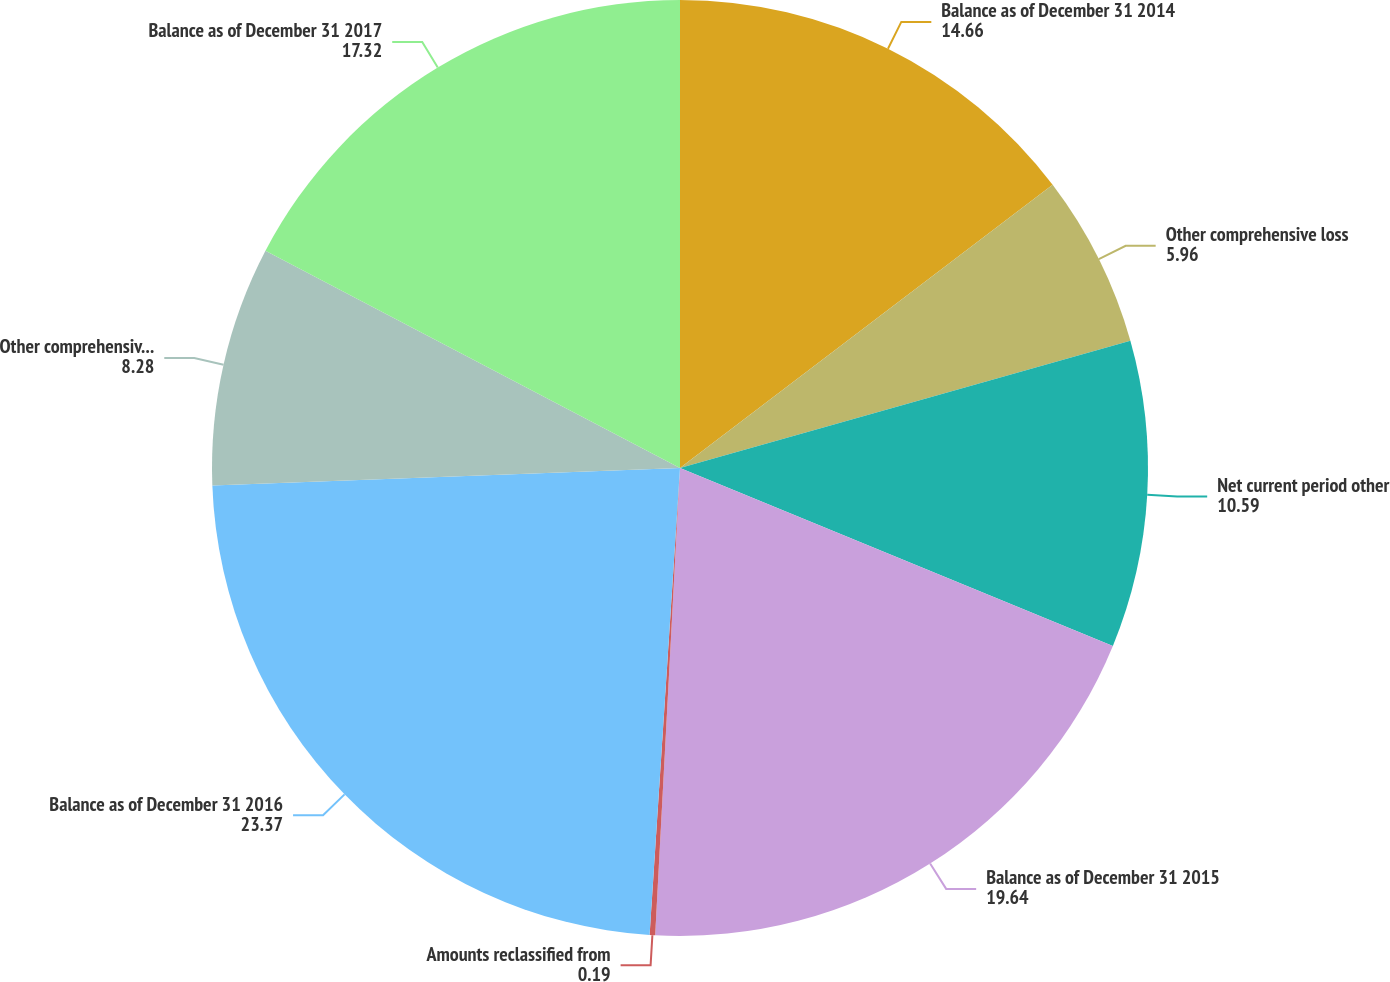<chart> <loc_0><loc_0><loc_500><loc_500><pie_chart><fcel>Balance as of December 31 2014<fcel>Other comprehensive loss<fcel>Net current period other<fcel>Balance as of December 31 2015<fcel>Amounts reclassified from<fcel>Balance as of December 31 2016<fcel>Other comprehensive income<fcel>Balance as of December 31 2017<nl><fcel>14.66%<fcel>5.96%<fcel>10.59%<fcel>19.64%<fcel>0.19%<fcel>23.37%<fcel>8.28%<fcel>17.32%<nl></chart> 